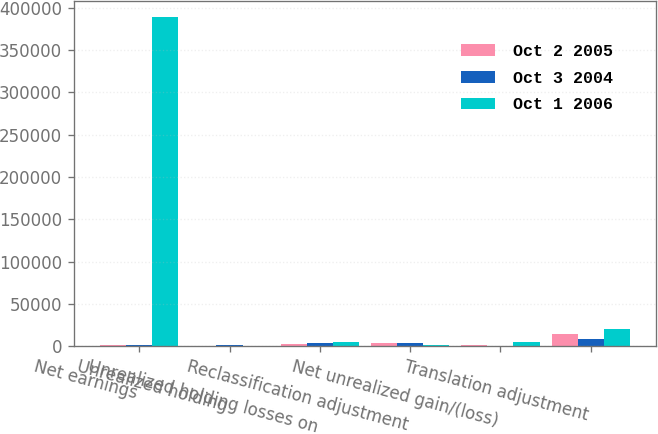<chart> <loc_0><loc_0><loc_500><loc_500><stacked_bar_chart><ecel><fcel>Net earnings<fcel>Unrealized holding<fcel>Unrealized holding losses on<fcel>Reclassification adjustment<fcel>Net unrealized gain/(loss)<fcel>Translation adjustment<nl><fcel>Oct 2 2005<fcel>1965.5<fcel>35<fcel>2803<fcel>4138<fcel>1767<fcel>14592<nl><fcel>Oct 3 2004<fcel>1965.5<fcel>1037<fcel>3861<fcel>3302<fcel>350<fcel>8677<nl><fcel>Oct 1 2006<fcel>388880<fcel>558<fcel>4769<fcel>1200<fcel>4925<fcel>19892<nl></chart> 